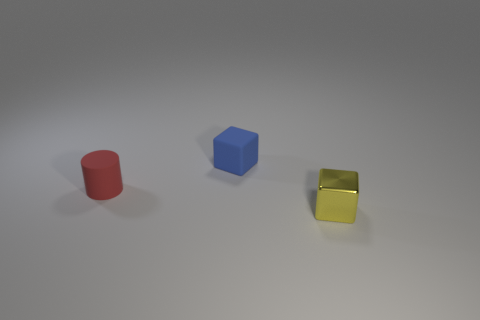Add 3 big blue metallic blocks. How many objects exist? 6 Subtract all blocks. How many objects are left? 1 Add 1 small rubber things. How many small rubber things are left? 3 Add 2 yellow cubes. How many yellow cubes exist? 3 Subtract 0 red balls. How many objects are left? 3 Subtract all tiny red shiny balls. Subtract all yellow shiny objects. How many objects are left? 2 